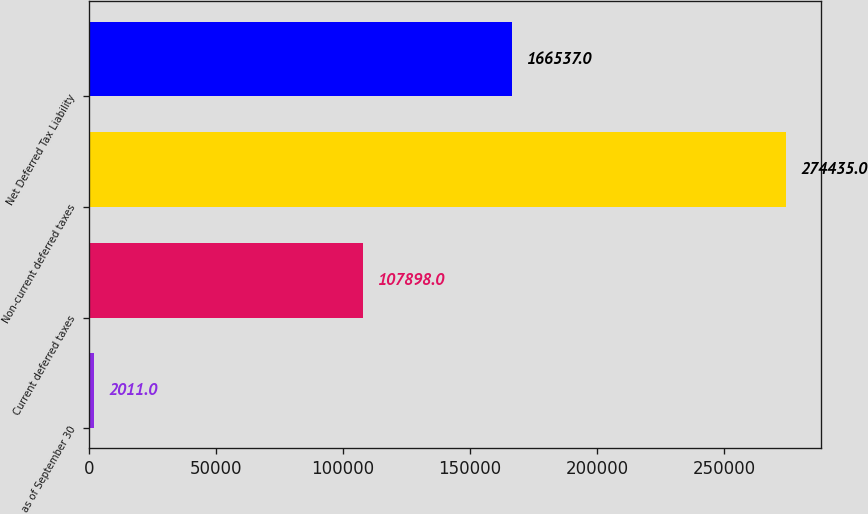Convert chart to OTSL. <chart><loc_0><loc_0><loc_500><loc_500><bar_chart><fcel>as of September 30<fcel>Current deferred taxes<fcel>Non-current deferred taxes<fcel>Net Deferred Tax Liability<nl><fcel>2011<fcel>107898<fcel>274435<fcel>166537<nl></chart> 